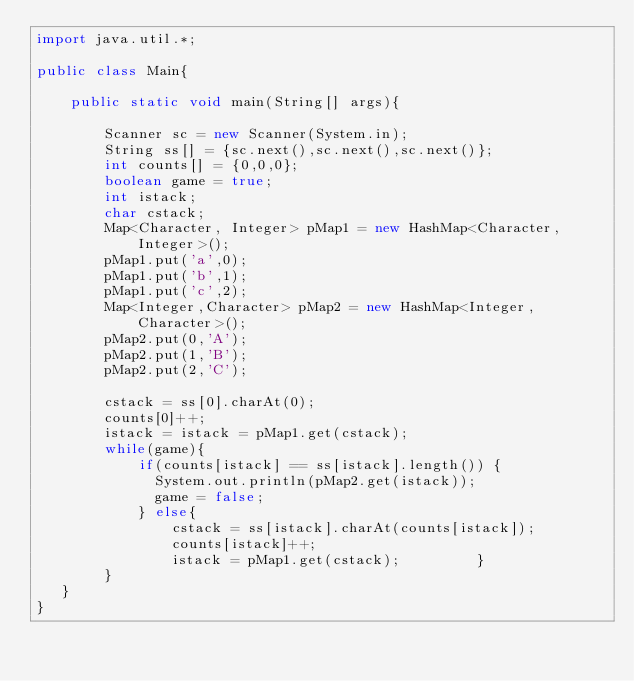Convert code to text. <code><loc_0><loc_0><loc_500><loc_500><_Java_>import java.util.*;
 
public class Main{
 
	public static void main(String[] args){
 
		Scanner sc = new Scanner(System.in);
        String ss[] = {sc.next(),sc.next(),sc.next()};
      	int counts[] = {0,0,0};
      	boolean game = true;
      	int istack;
      	char cstack;
      	Map<Character, Integer> pMap1 = new HashMap<Character, Integer>();
		pMap1.put('a',0);
      	pMap1.put('b',1);
      	pMap1.put('c',2);
      	Map<Integer,Character> pMap2 = new HashMap<Integer,Character>();
		pMap2.put(0,'A');
      	pMap2.put(1,'B');
      	pMap2.put(2,'C');
      	
      	cstack = ss[0].charAt(0);
      	counts[0]++;
      	istack = istack = pMap1.get(cstack);
       	while(game){
          	if(counts[istack] == ss[istack].length()) {
              System.out.println(pMap2.get(istack));
              game = false;
            } else{            	              	
              	cstack = ss[istack].charAt(counts[istack]); 
                counts[istack]++;
              	istack = pMap1.get(cstack);         }
        }
   }
}
</code> 